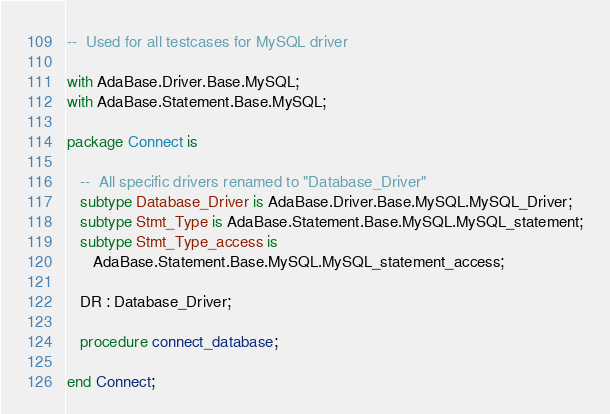<code> <loc_0><loc_0><loc_500><loc_500><_Ada_>--  Used for all testcases for MySQL driver

with AdaBase.Driver.Base.MySQL;
with AdaBase.Statement.Base.MySQL;

package Connect is

   --  All specific drivers renamed to "Database_Driver"
   subtype Database_Driver is AdaBase.Driver.Base.MySQL.MySQL_Driver;
   subtype Stmt_Type is AdaBase.Statement.Base.MySQL.MySQL_statement;
   subtype Stmt_Type_access is
      AdaBase.Statement.Base.MySQL.MySQL_statement_access;

   DR : Database_Driver;

   procedure connect_database;

end Connect;
</code> 